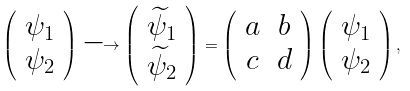<formula> <loc_0><loc_0><loc_500><loc_500>\left ( \begin{array} { c } \psi _ { 1 } \\ \psi _ { 2 } \end{array} \right ) \longrightarrow \left ( \begin{array} { c } \widetilde { \psi } _ { 1 } \\ \widetilde { \psi } _ { 2 } \end{array} \right ) = \left ( \begin{array} { c } a \\ c \end{array} \begin{array} { c c } b \\ d \end{array} \right ) \left ( \begin{array} { c } \psi _ { 1 } \\ \psi _ { 2 } \end{array} \right ) ,</formula> 